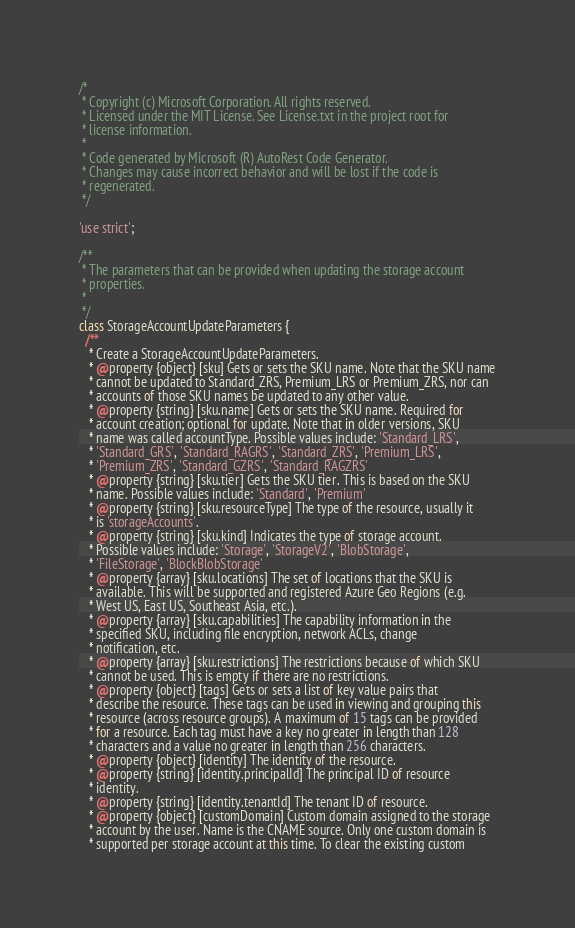Convert code to text. <code><loc_0><loc_0><loc_500><loc_500><_JavaScript_>/*
 * Copyright (c) Microsoft Corporation. All rights reserved.
 * Licensed under the MIT License. See License.txt in the project root for
 * license information.
 *
 * Code generated by Microsoft (R) AutoRest Code Generator.
 * Changes may cause incorrect behavior and will be lost if the code is
 * regenerated.
 */

'use strict';

/**
 * The parameters that can be provided when updating the storage account
 * properties.
 *
 */
class StorageAccountUpdateParameters {
  /**
   * Create a StorageAccountUpdateParameters.
   * @property {object} [sku] Gets or sets the SKU name. Note that the SKU name
   * cannot be updated to Standard_ZRS, Premium_LRS or Premium_ZRS, nor can
   * accounts of those SKU names be updated to any other value.
   * @property {string} [sku.name] Gets or sets the SKU name. Required for
   * account creation; optional for update. Note that in older versions, SKU
   * name was called accountType. Possible values include: 'Standard_LRS',
   * 'Standard_GRS', 'Standard_RAGRS', 'Standard_ZRS', 'Premium_LRS',
   * 'Premium_ZRS', 'Standard_GZRS', 'Standard_RAGZRS'
   * @property {string} [sku.tier] Gets the SKU tier. This is based on the SKU
   * name. Possible values include: 'Standard', 'Premium'
   * @property {string} [sku.resourceType] The type of the resource, usually it
   * is 'storageAccounts'.
   * @property {string} [sku.kind] Indicates the type of storage account.
   * Possible values include: 'Storage', 'StorageV2', 'BlobStorage',
   * 'FileStorage', 'BlockBlobStorage'
   * @property {array} [sku.locations] The set of locations that the SKU is
   * available. This will be supported and registered Azure Geo Regions (e.g.
   * West US, East US, Southeast Asia, etc.).
   * @property {array} [sku.capabilities] The capability information in the
   * specified SKU, including file encryption, network ACLs, change
   * notification, etc.
   * @property {array} [sku.restrictions] The restrictions because of which SKU
   * cannot be used. This is empty if there are no restrictions.
   * @property {object} [tags] Gets or sets a list of key value pairs that
   * describe the resource. These tags can be used in viewing and grouping this
   * resource (across resource groups). A maximum of 15 tags can be provided
   * for a resource. Each tag must have a key no greater in length than 128
   * characters and a value no greater in length than 256 characters.
   * @property {object} [identity] The identity of the resource.
   * @property {string} [identity.principalId] The principal ID of resource
   * identity.
   * @property {string} [identity.tenantId] The tenant ID of resource.
   * @property {object} [customDomain] Custom domain assigned to the storage
   * account by the user. Name is the CNAME source. Only one custom domain is
   * supported per storage account at this time. To clear the existing custom</code> 